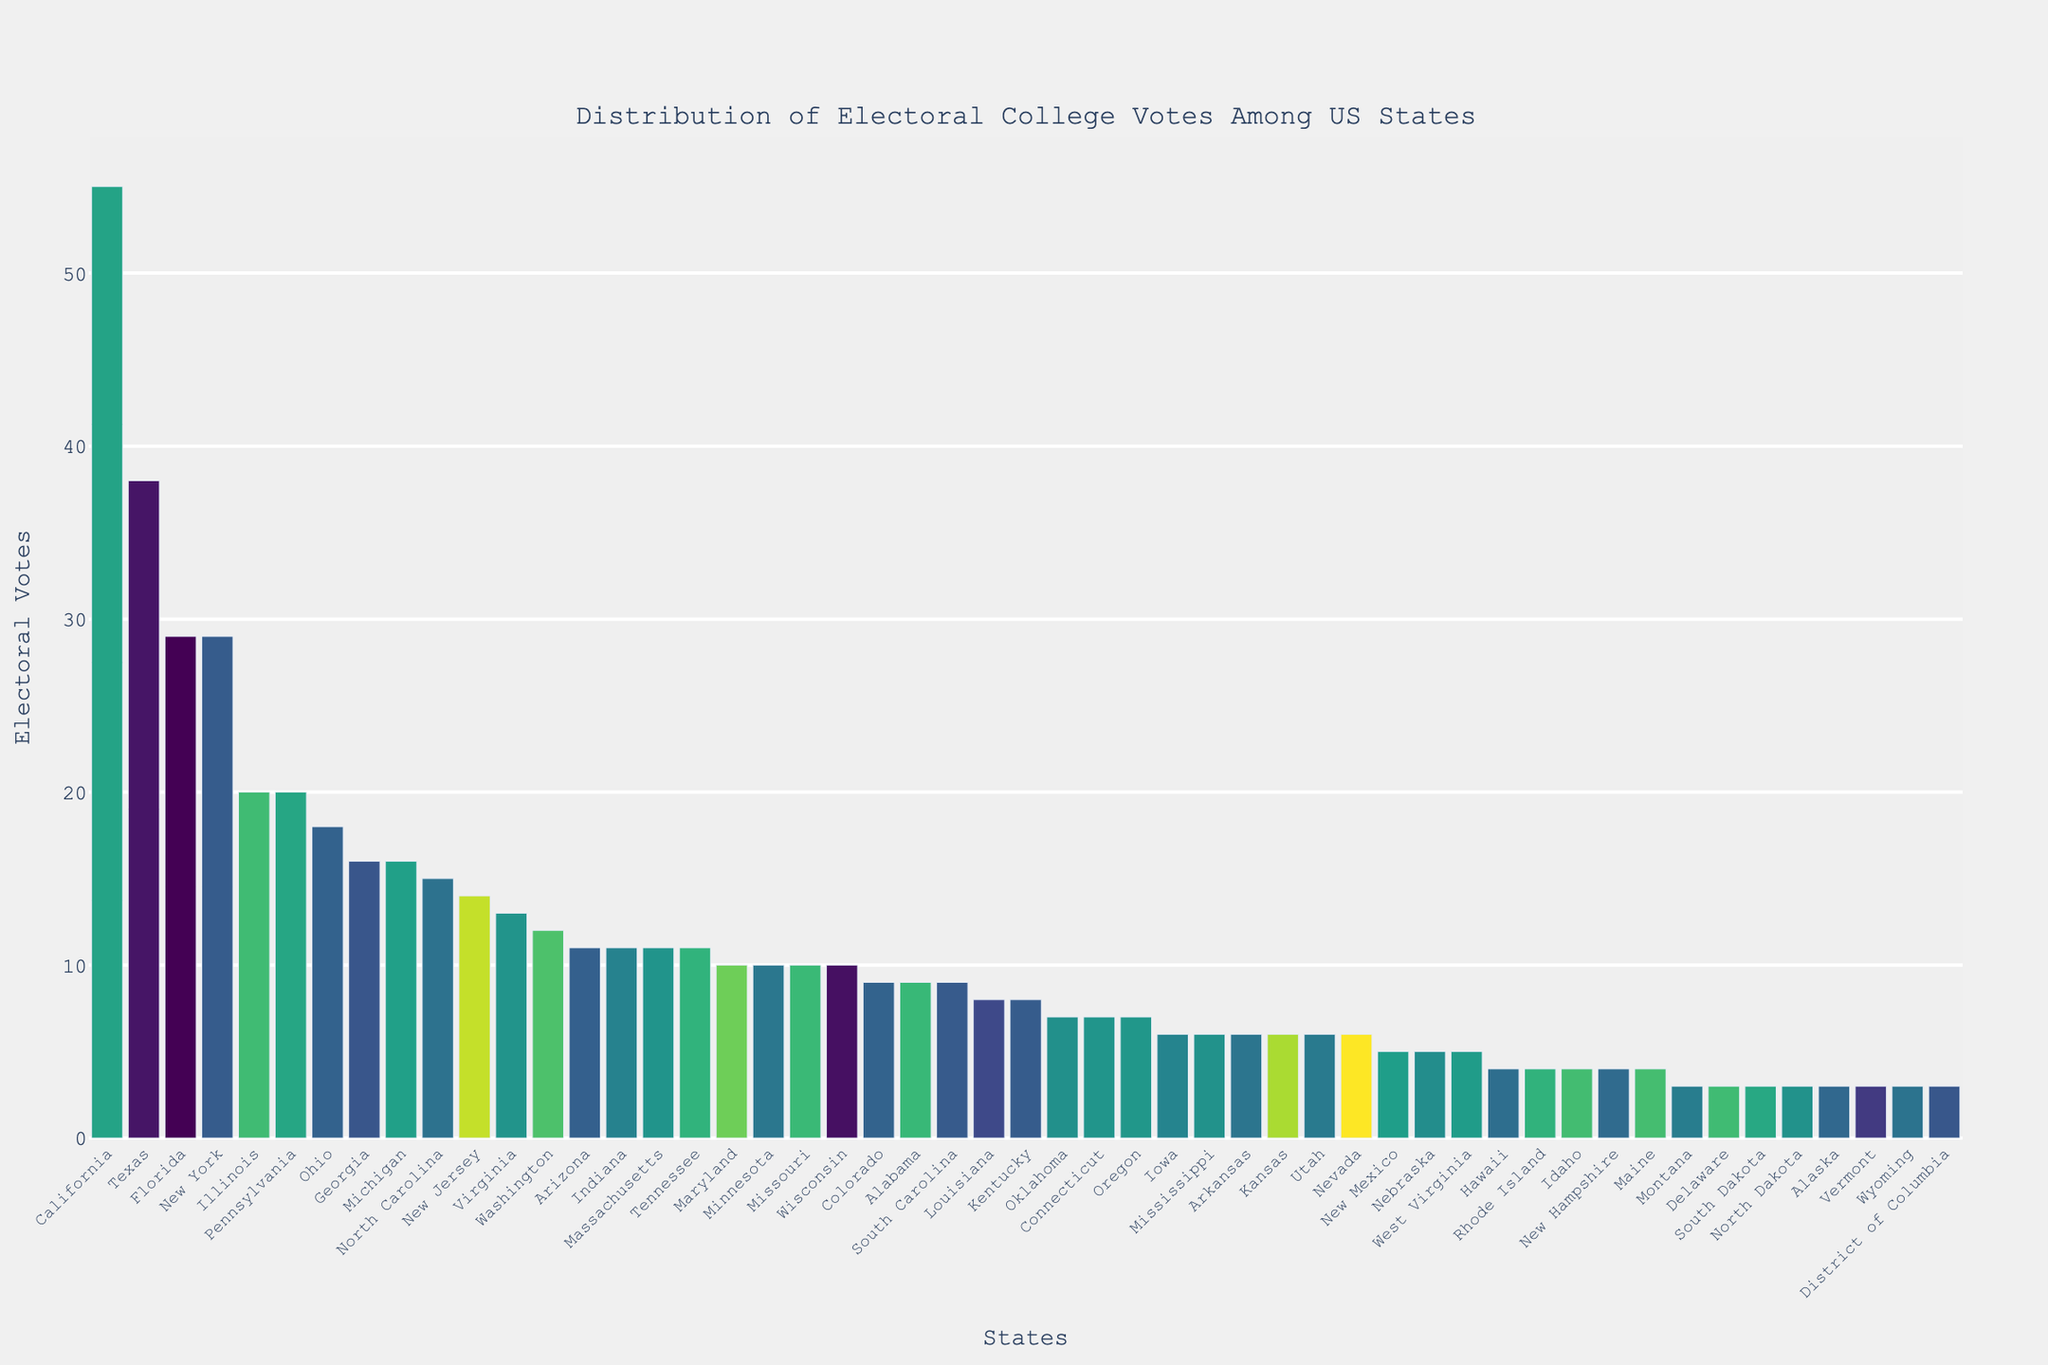What's the state with the highest number of electoral votes? Look for the state with the tallest bar in the bar chart. California has the tallest bar, indicating it has the highest number of electoral votes.
Answer: California Which states have exactly 29 electoral votes? Identify the states that have bars reaching the 29 electoral votes mark. Florida and New York both have bars reaching to 29 electoral votes.
Answer: Florida, New York What is the total number of electoral votes for the states with the lowest number of electoral votes? Identify the states with the lowest number of votes (3 votes). Sum their electoral votes: There are 8 states (Montana, Delaware, South Dakota, North Dakota, Alaska, Vermont, Wyoming, District of Columbia) each with 3 votes. Calculate 3 * 8 = 24.
Answer: 24 How many states have more than 20 electoral votes? Count the number of bars that exceed the 20 electoral vote mark. These include California, Texas, Florida, New York, Illinois, and Pennsylvania.
Answer: 6 Which state has fewer electoral votes: Virginia or New Jersey? Compare the height of the bars representing Virginia (13) and New Jersey (14). New Jersey has 14 and Virginia has 13.
Answer: Virginia What is the combined electoral vote count of Ohio, Georgia, and Michigan? Find the electoral votes for each state and sum them: Ohio (18), Georgia (16), Michigan (16). Calculate 18 + 16 + 16 = 50.
Answer: 50 Are there more states with exactly 10 electoral votes or exactly 6 electoral votes? Count the number of states at the 10 and 6 electoral vote levels. For 10: Maryland, Minnesota, Missouri, Wisconsin (4 states). For 6: Iowa, Mississippi, Arkansas, Kansas, Utah, Nevada (6 states). More states have exactly 6 electoral votes.
Answer: 10 electoral votes How does the number of electoral votes for Texas compare to the combined total of Colorado, Alabama, and South Carolina? Find the electoral votes for Texas (38) and sum those for Colorado (9), Alabama (9), and South Carolina (9). Check 9 + 9 + 9 = 27. Texas has more (38) compared to 27.
Answer: Texas has more 